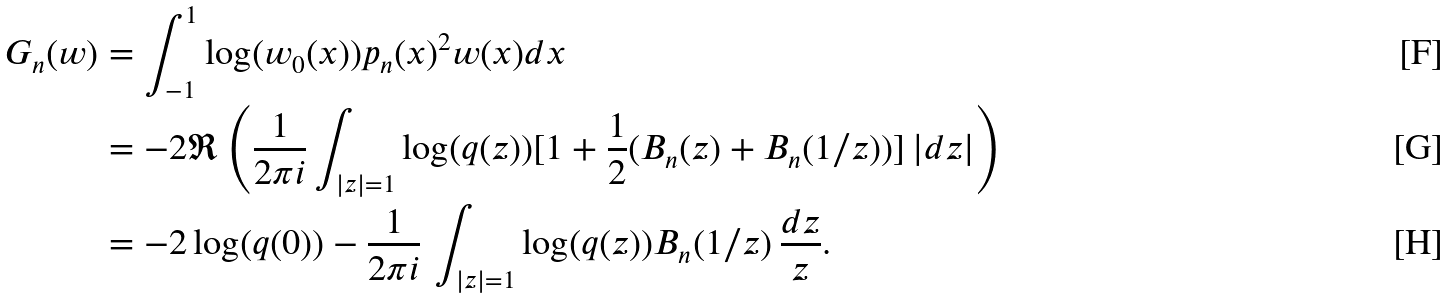<formula> <loc_0><loc_0><loc_500><loc_500>G _ { n } ( w ) & = \int _ { - 1 } ^ { 1 } \log ( w _ { 0 } ( x ) ) p _ { n } ( x ) ^ { 2 } w ( x ) d x \\ & = - 2 \Re \left ( \frac { 1 } { 2 \pi i } \int _ { | z | = 1 } \log ( q ( z ) ) [ 1 + \frac { 1 } { 2 } ( B _ { n } ( z ) + B _ { n } ( 1 / z ) ) ] \, | d z | \right ) \\ & = - 2 \log ( q ( 0 ) ) - \frac { 1 } { 2 \pi i } \, \int _ { | z | = 1 } \log ( q ( z ) ) B _ { n } ( 1 / z ) \, \frac { d z } { z } .</formula> 